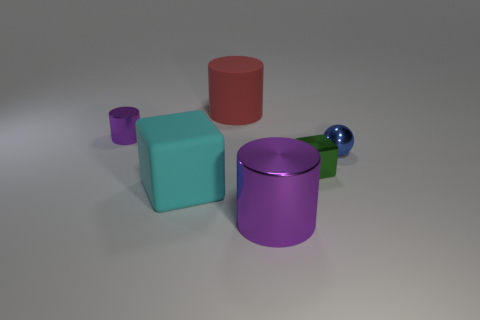Add 2 tiny green metal cubes. How many objects exist? 8 Subtract all big purple metallic cylinders. How many cylinders are left? 2 Subtract all red cylinders. How many cylinders are left? 2 Subtract all balls. How many objects are left? 5 Subtract 1 blocks. How many blocks are left? 1 Subtract 1 green cubes. How many objects are left? 5 Subtract all red cubes. Subtract all gray balls. How many cubes are left? 2 Subtract all gray spheres. How many red cylinders are left? 1 Subtract all small yellow things. Subtract all green metallic objects. How many objects are left? 5 Add 2 large matte things. How many large matte things are left? 4 